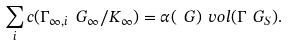Convert formula to latex. <formula><loc_0><loc_0><loc_500><loc_500>\sum _ { i } c ( \Gamma _ { \infty , i } \ G _ { \infty } / K _ { \infty } ) = \alpha ( \ G ) \ v o l ( \Gamma \ G _ { S } ) .</formula> 